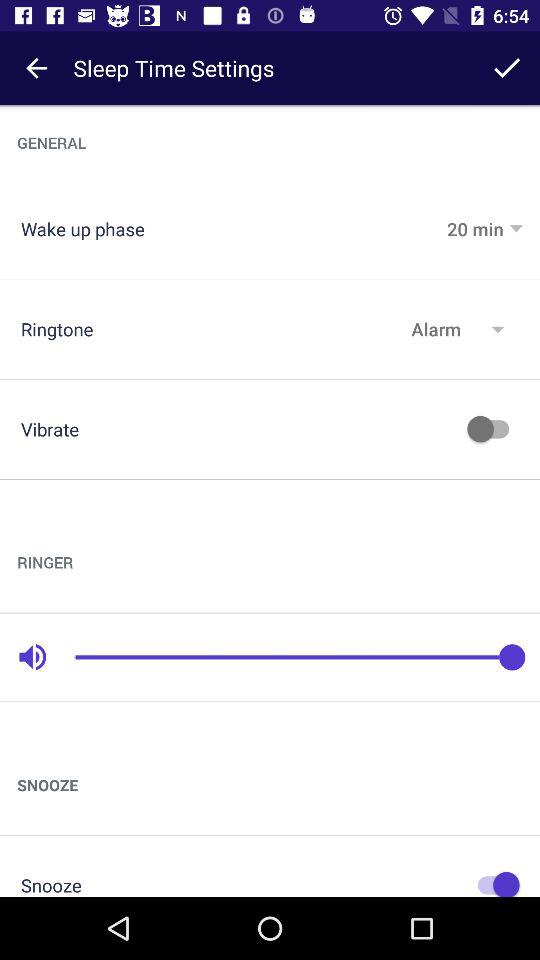What is "Wake up phase" time? "Wake up phase" time is 20 minutes. 